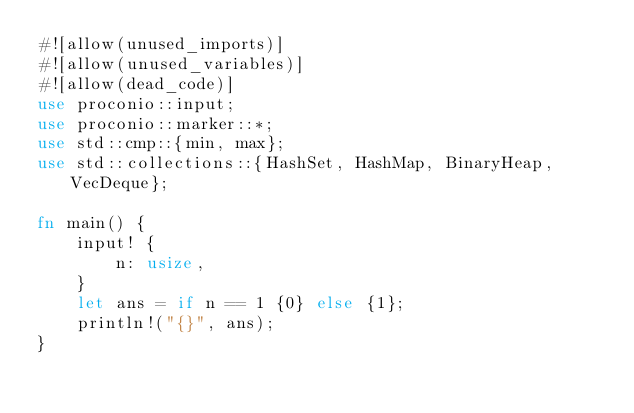Convert code to text. <code><loc_0><loc_0><loc_500><loc_500><_Rust_>#![allow(unused_imports)]
#![allow(unused_variables)]
#![allow(dead_code)]
use proconio::input;
use proconio::marker::*;
use std::cmp::{min, max};
use std::collections::{HashSet, HashMap, BinaryHeap, VecDeque};

fn main() {
    input! {
        n: usize,
    }
    let ans = if n == 1 {0} else {1};
    println!("{}", ans);
}
</code> 